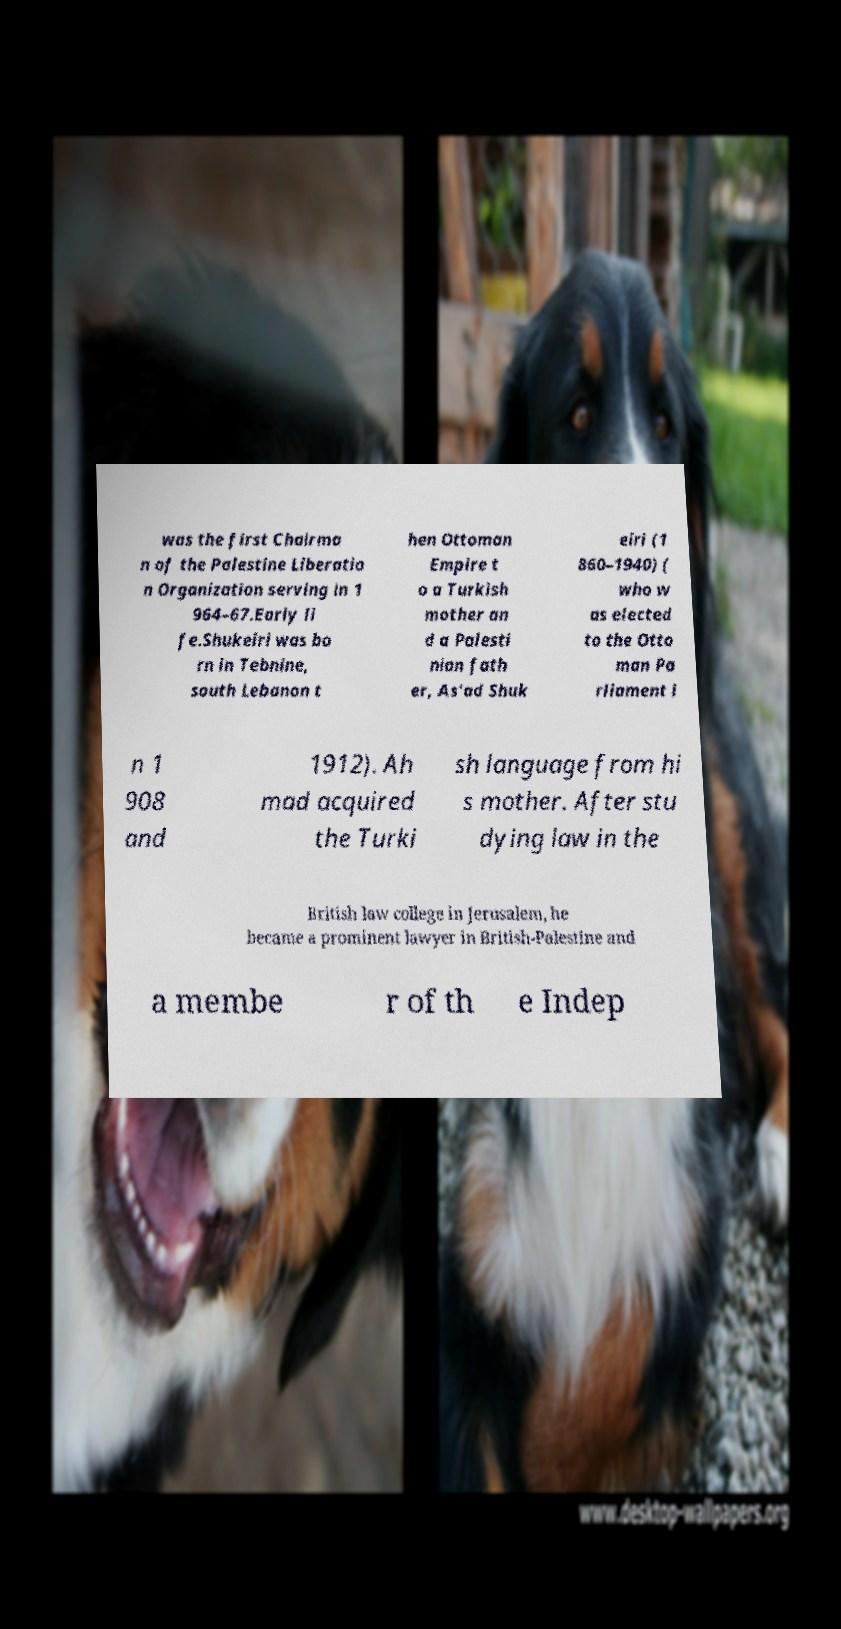Please read and relay the text visible in this image. What does it say? was the first Chairma n of the Palestine Liberatio n Organization serving in 1 964–67.Early li fe.Shukeiri was bo rn in Tebnine, south Lebanon t hen Ottoman Empire t o a Turkish mother an d a Palesti nian fath er, As'ad Shuk eiri (1 860–1940) ( who w as elected to the Otto man Pa rliament i n 1 908 and 1912). Ah mad acquired the Turki sh language from hi s mother. After stu dying law in the British law college in Jerusalem, he became a prominent lawyer in British-Palestine and a membe r of th e Indep 